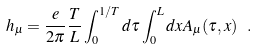Convert formula to latex. <formula><loc_0><loc_0><loc_500><loc_500>h _ { \mu } = \frac { e } { 2 \pi } \frac { T } { L } \int _ { 0 } ^ { 1 / T } d \tau \int _ { 0 } ^ { L } d x A _ { \mu } ( \tau , x ) \ .</formula> 